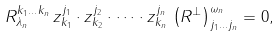<formula> <loc_0><loc_0><loc_500><loc_500>R _ { \lambda _ { n } } ^ { k _ { 1 } \dots k _ { n } } \, z _ { k _ { 1 } } ^ { j _ { 1 } } \cdot z _ { k _ { 2 } } ^ { j _ { 2 } } \cdot \dots \cdot z _ { k _ { n } } ^ { j _ { n } } \, \left ( R ^ { \bot } \right ) _ { j _ { 1 } \dots j _ { n } } ^ { \omega _ { n } } = 0 ,</formula> 